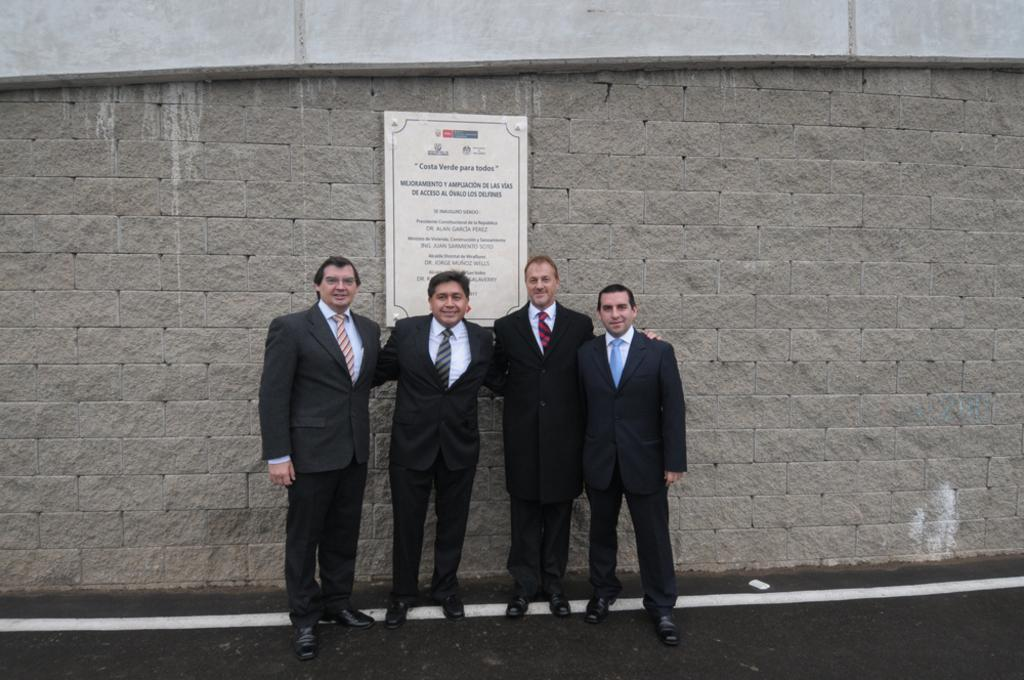How many people are present in the image? There are four people in the image. What are the people wearing? The people are wearing black suits. What can be seen in the background of the image? There is a brick wall in the background of the image. Is there any additional information on the wall? Yes, there is a poster on the wall. Can you tell me how the powder is being used by the people in the image? There is no powder present in the image; the people are wearing black suits. Is there a river visible in the image? No, there is no river visible in the image; the background features a brick wall and a poster. 